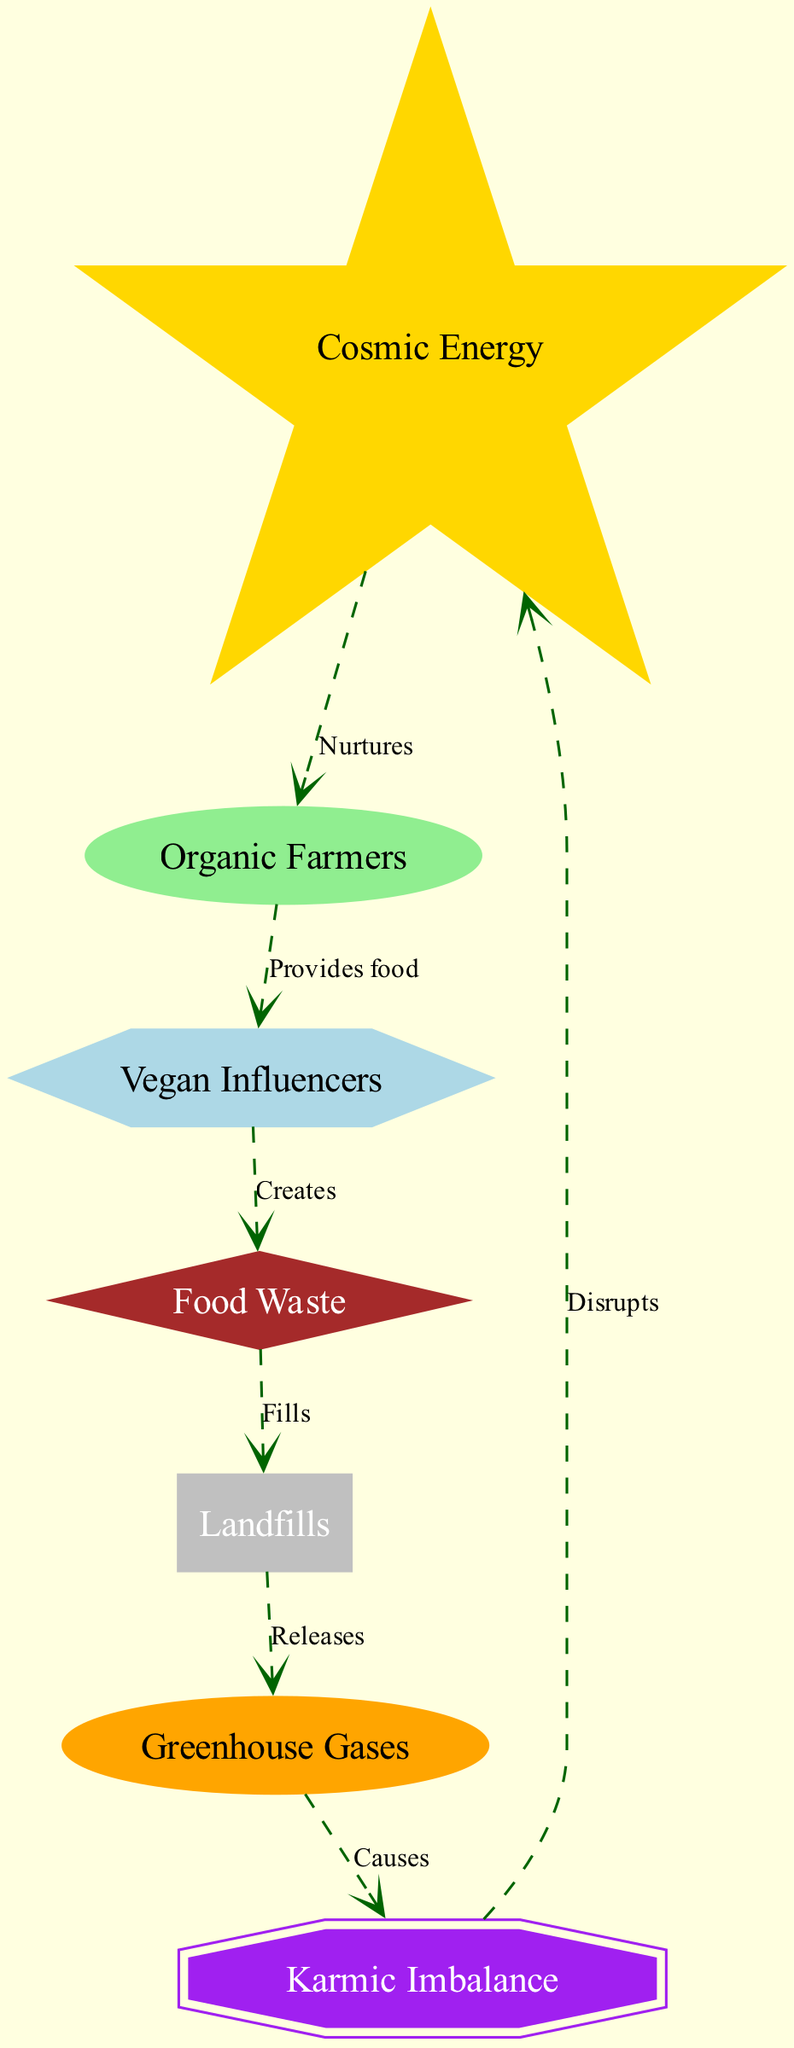What is the role of Organic Farmers in the food chain? Organic Farmers are labeled as primary consumers in the diagram and they acquire energy from Cosmic Energy. They process this energy into food.
Answer: primary consumer How many nodes are there in the diagram? By counting all distinct elements listed, we find there are seven nodes labeled from Cosmic Energy to Karmic Imbalance.
Answer: 7 What do Vegan Influencers create? The connection shows that Vegan Influencers create Food Waste, indicating their role in the cycle leads to waste production.
Answer: Food Waste What is released by Landfills? The diagram indicates that Landfills release Greenhouse Gases, which are a significant environmental output.
Answer: Greenhouse Gases How does Karmic Imbalance affect Cosmic Energy? Karmic Imbalance causes disruption to Cosmic Energy as indicated by the connection type, highlighting the negative feedback loop in the cycle.
Answer: Disrupts What type of element is Food Waste in the diagram? Food Waste is categorized as a decomposer, which implies its role in breaking down organic matter within the food chain.
Answer: decomposer What happens to the Greenhouse Gases? Greenhouse Gases cause Karmic Imbalance as shown in the connection between these outputs and their resulting effects.
Answer: Causes What is the source of energy for Organic Farmers? The source of energy comes from Cosmic Energy, which nurtures the organic farming process.
Answer: Cosmic Energy How many connections are there in total? Counting all the listed connections shows there are six links that depict the flow within the food chain.
Answer: 6 